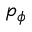Convert formula to latex. <formula><loc_0><loc_0><loc_500><loc_500>p _ { \phi }</formula> 